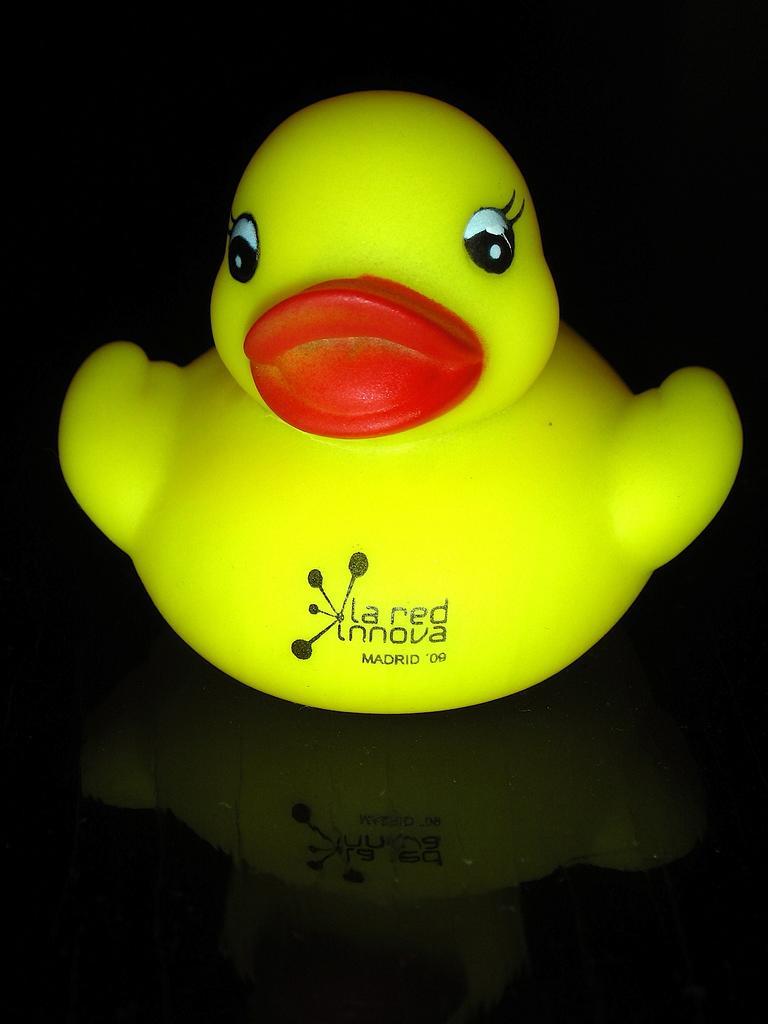Could you give a brief overview of what you see in this image? In the center of the image we can see a duck toy placed on the table. 